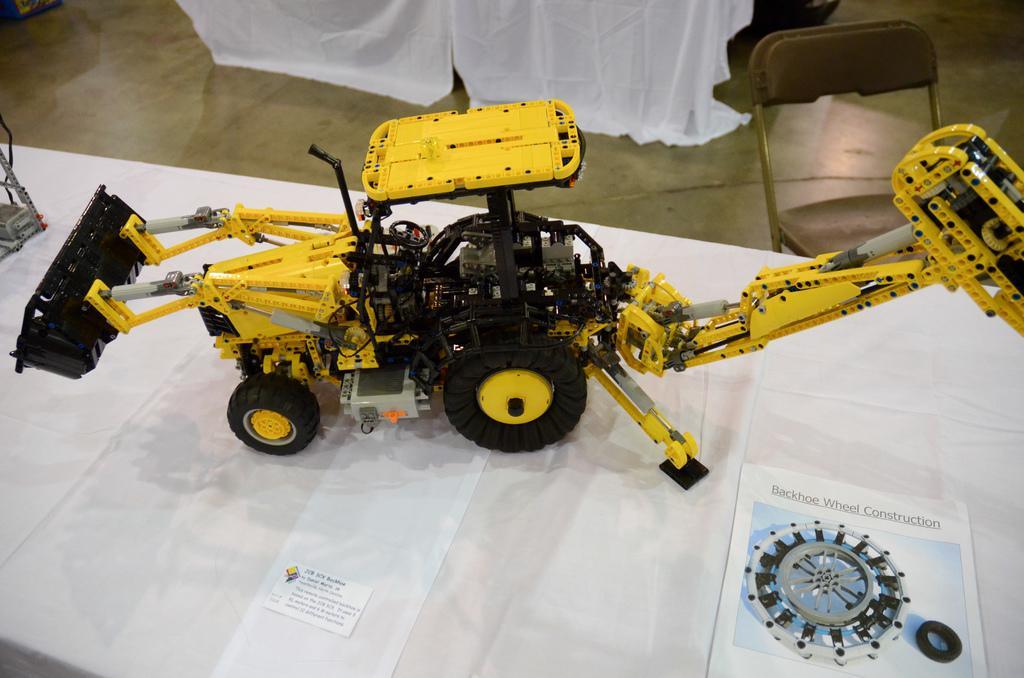How would you summarize this image in a sentence or two? A toy crane is kept on a table. On the table there is a white cloth with some papers. In the background there is a chair. 